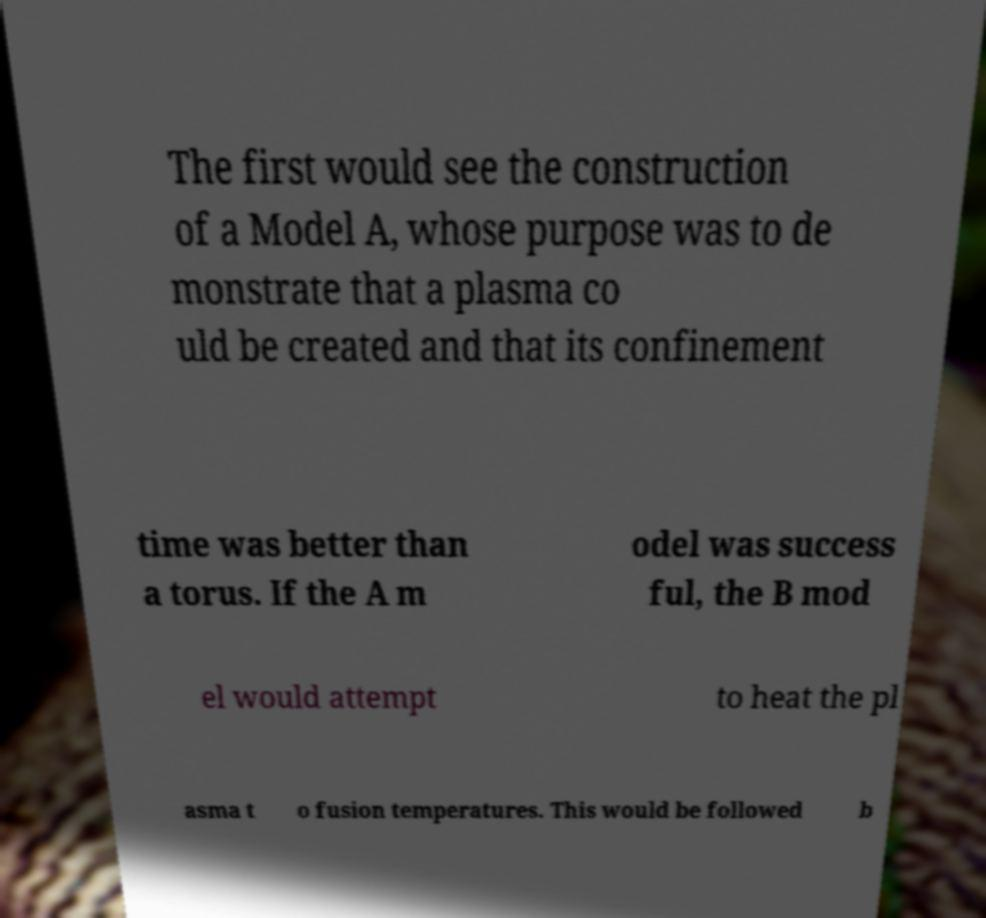Please read and relay the text visible in this image. What does it say? The first would see the construction of a Model A, whose purpose was to de monstrate that a plasma co uld be created and that its confinement time was better than a torus. If the A m odel was success ful, the B mod el would attempt to heat the pl asma t o fusion temperatures. This would be followed b 